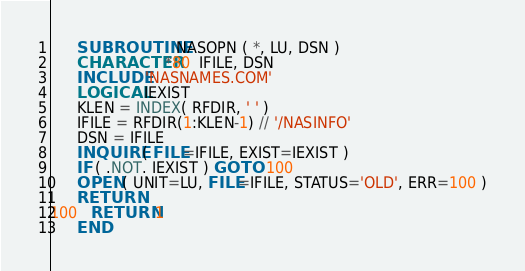Convert code to text. <code><loc_0><loc_0><loc_500><loc_500><_FORTRAN_>      SUBROUTINE NASOPN ( *, LU, DSN )
      CHARACTER*80  IFILE, DSN
      INCLUDE 'NASNAMES.COM'
      LOGICAL IEXIST
      KLEN = INDEX( RFDIR, ' ' )
      IFILE = RFDIR(1:KLEN-1) // '/NASINFO'
      DSN = IFILE
      INQUIRE ( FILE=IFILE, EXIST=IEXIST )
      IF ( .NOT. IEXIST ) GO TO 100
      OPEN ( UNIT=LU, FILE=IFILE, STATUS='OLD', ERR=100 )
      RETURN
100   RETURN 1
      END
</code> 